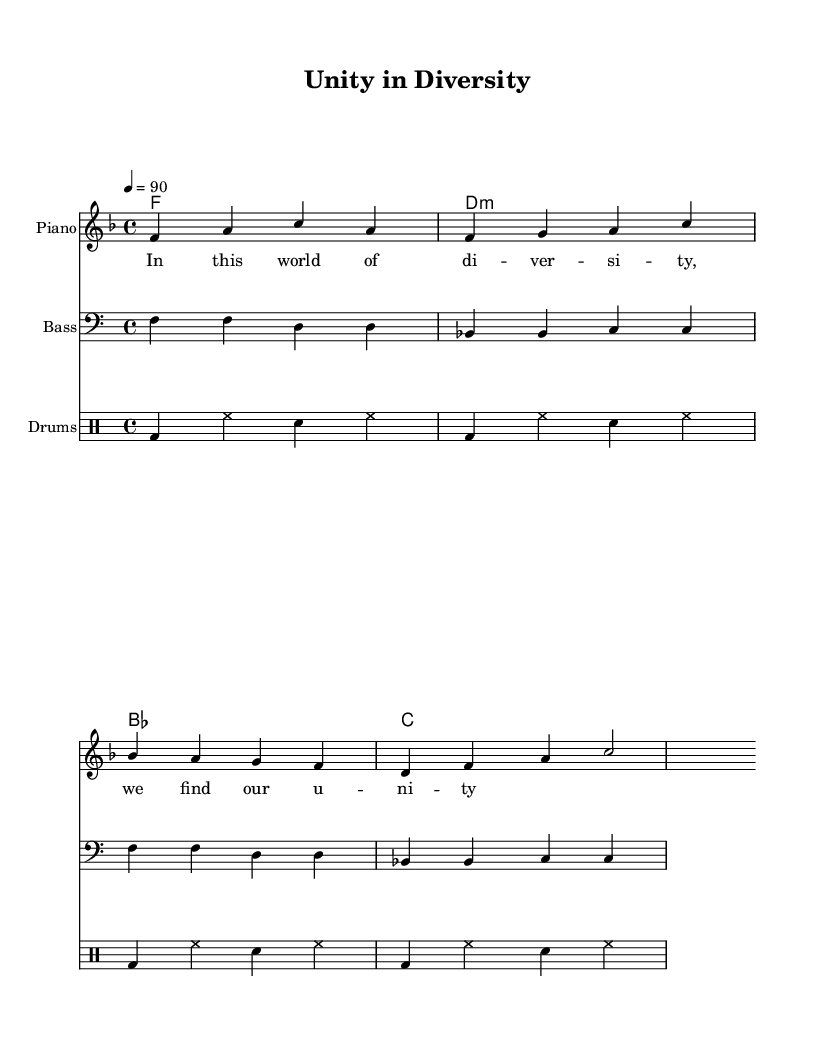What is the key signature of this music? The key signature of the piece is F major, which has one flat (B♭). This is indicated at the beginning of the score.
Answer: F major What is the time signature of this piece? The time signature is indicated at the beginning of the score and is 4/4, meaning there are four beats in each measure and the quarter note gets one beat.
Answer: 4/4 What is the tempo marking for this music? The tempo marking is given as a quarter note equals 90 beats per minute, indicated at the beginning of the score.
Answer: 90 How many measures are present in the melody? By counting the measures in the melody section, there are four measures total, each clearly delineated by vertical lines.
Answer: 4 What type of chords are primarily used in the harmony section? The harmony section shows that the chords include F major, D minor, B flat major, and C major. These are listed as chord names above the staff.
Answer: Major and minor What is the primary lyrical theme of the piece? The lyrics express a message of unity in diversity, which is highlighted in the first line, emphasizing the importance of finding unity amidst differences.
Answer: Unity in diversity What rhythmic pattern is frequently used in the drum section? The drum patterns show a sequence that emphasizes the bass drum and hi-hat, creating a consistent hip hop rhythmic feel throughout the score.
Answer: Bass and hi-hat 